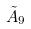Convert formula to latex. <formula><loc_0><loc_0><loc_500><loc_500>\tilde { A } _ { 9 }</formula> 